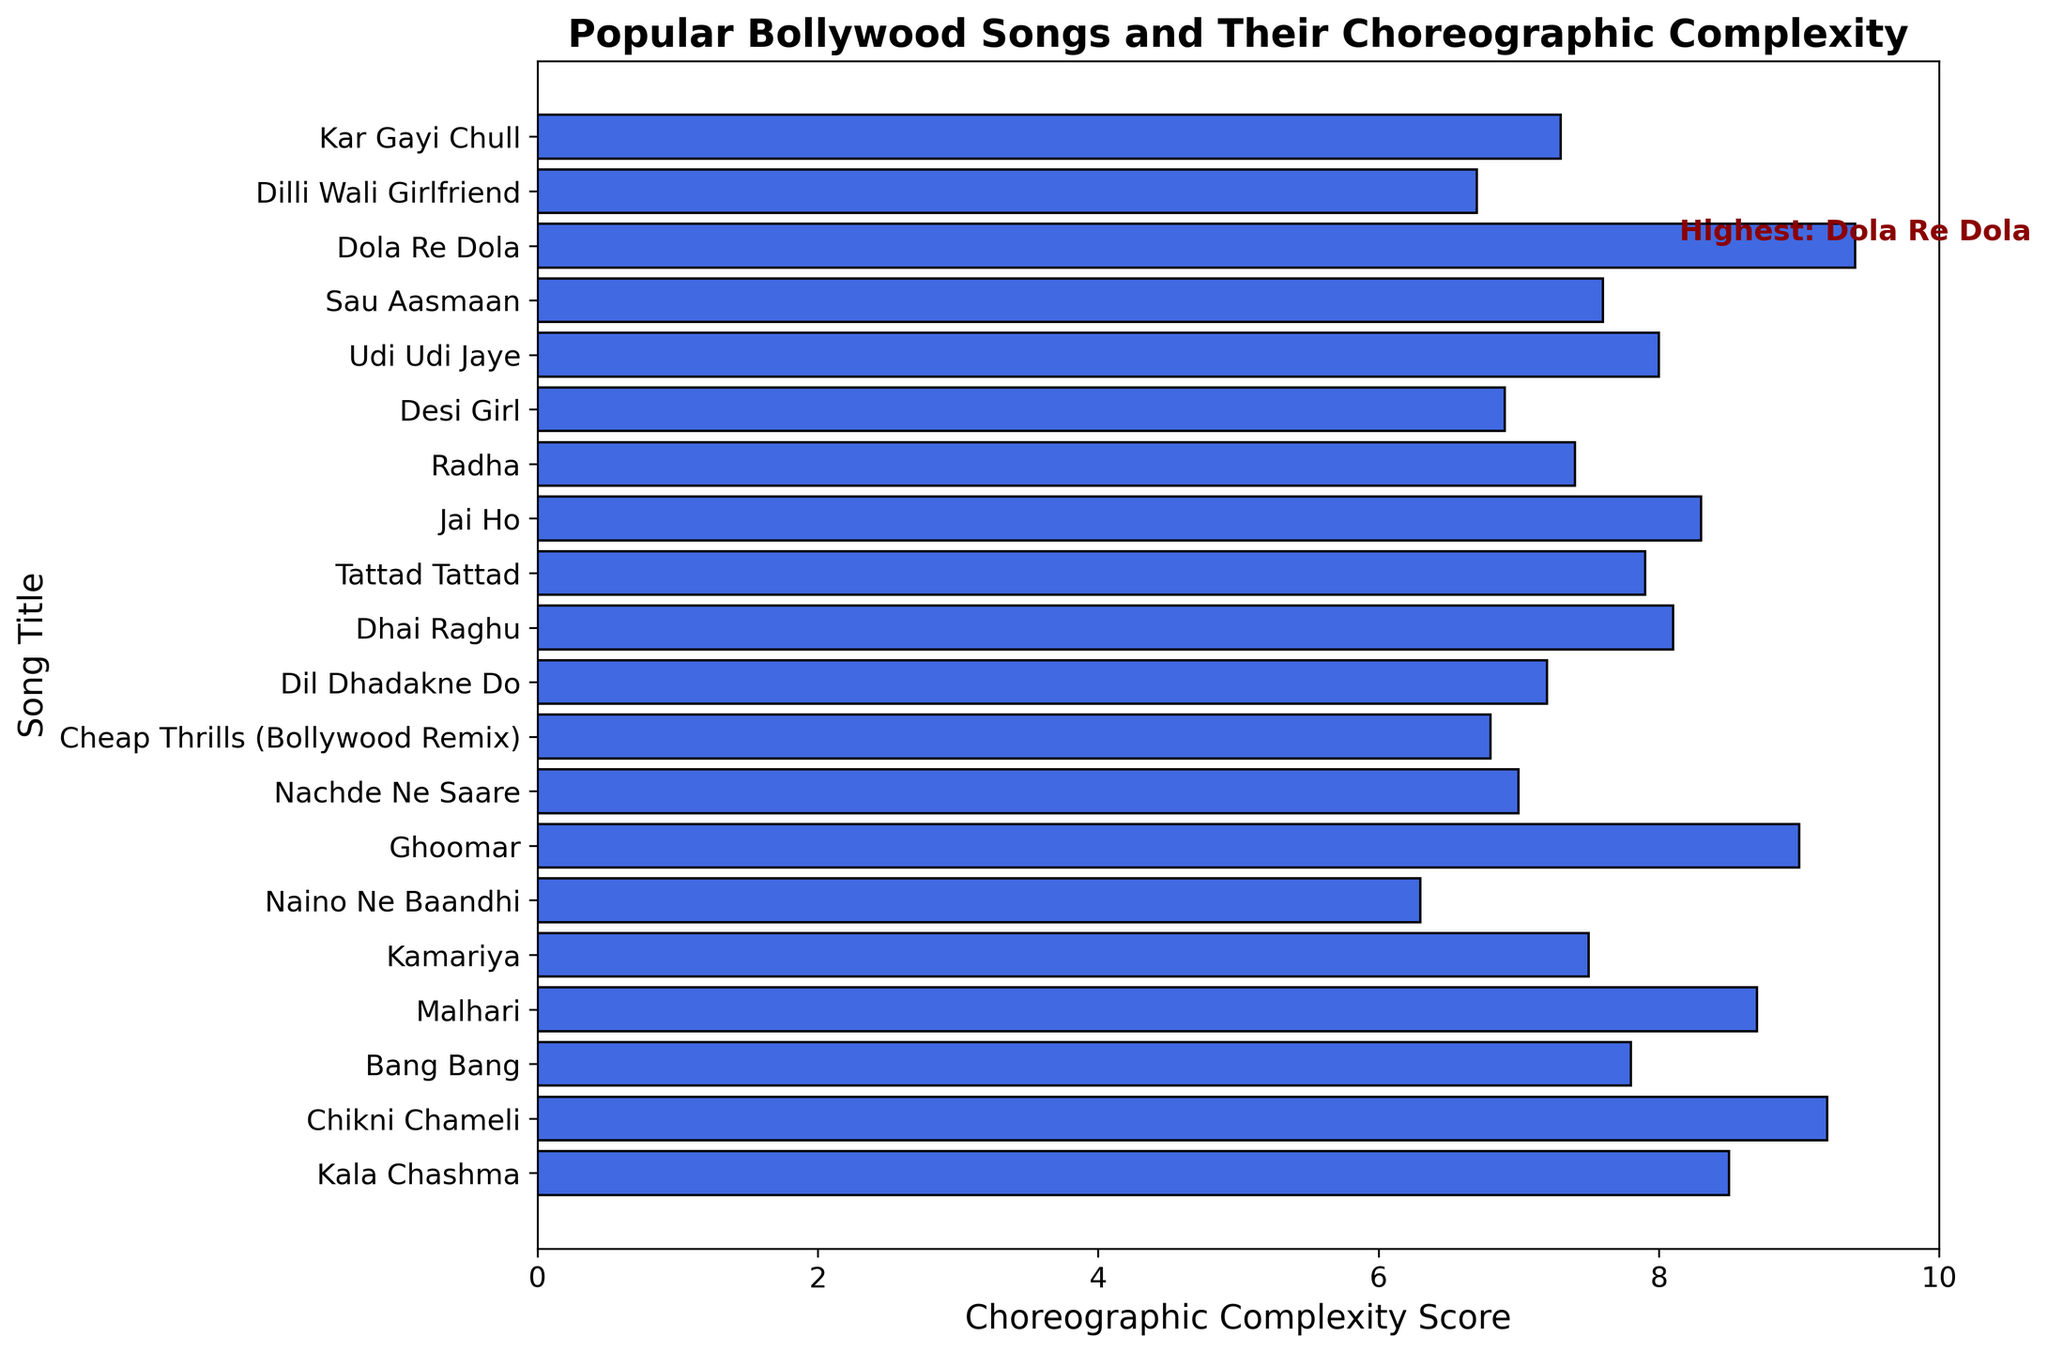What is the choreographic complexity score of "Ghoomar"? Look for the bar labeled "Ghoomar" and read the corresponding value on the x-axis, which is the choreographic complexity score.
Answer: 9.0 Which song has the highest choreographic complexity score? Identify the bar that extends the farthest to the right; the song associated with this bar is the one with the highest score. The annotation also points out the highest score.
Answer: "Dola Re Dola" What is the difference in choreographic complexity scores between "Kala Chashma" and "Chikni Chameli"? Locate both songs on the y-axis and find the corresponding scores on the x-axis. Subtract the score of "Kala Chashma" from "Chikni Chameli". The scores are 8.5 and 9.2 respectively. Therefore, 9.2 - 8.5
Answer: 0.7 Which song has a lower choreographic complexity score: "Kamariya" or "Udi Udi Jaye"? Compare the lengths of the bars for "Kamariya" and "Udi Udi Jaye". The score for "Kamariya" is 7.5 and for "Udi Udi Jaye" is 8.0.
Answer: "Kamariya" What is the choreographic complexity score for the song "Bang Bang"? Look for the bar labeled "Bang Bang" and read the corresponding value on the x-axis, which is the choreographic complexity score.
Answer: 7.8 How many songs have a choreographic complexity score greater than 8? Count the number of bars that extend past the value of 8 on the x-axis. These include: "Chikni Chameli", "Dola Re Dola", "Ghoomar", "Malhari", "Kala Chashma" and "Jai Ho".
Answer: 6 Which song has the second highest choreographic complexity score? Identify the two bars that extend the farthest to the right and identify the one that is not the farthest right. According to the chart, "Dola Re Dola" has the highest and "Chikni Chameli" the second highest.
Answer: "Chikni Chameli" What is the average choreographic complexity score of the songs "Cheap Thrills (Bollywood Remix)", "Radha", and "Kamariya"? Find the scores of the three songs listed: 6.8, 7.4, and 7.5. Sum these values: 6.8 + 7.4 + 7.5 = 21.7. Then, divide by the number of songs, which is 3. 21.7 / 3
Answer: 7.23 Which song has the lowest choreographic complexity score? Identify the shortest bar in the chart and read the song title associated with it.
Answer: "Naino Ne Baandhi" What is the combined score of "Desi Girl" and "Dhai Raghu"? Identify the scores for "Desi Girl" and "Dhai Raghu" which are 6.9 and 8.1 respectively. Add these scores together: 6.9 + 8.1
Answer: 15.0 